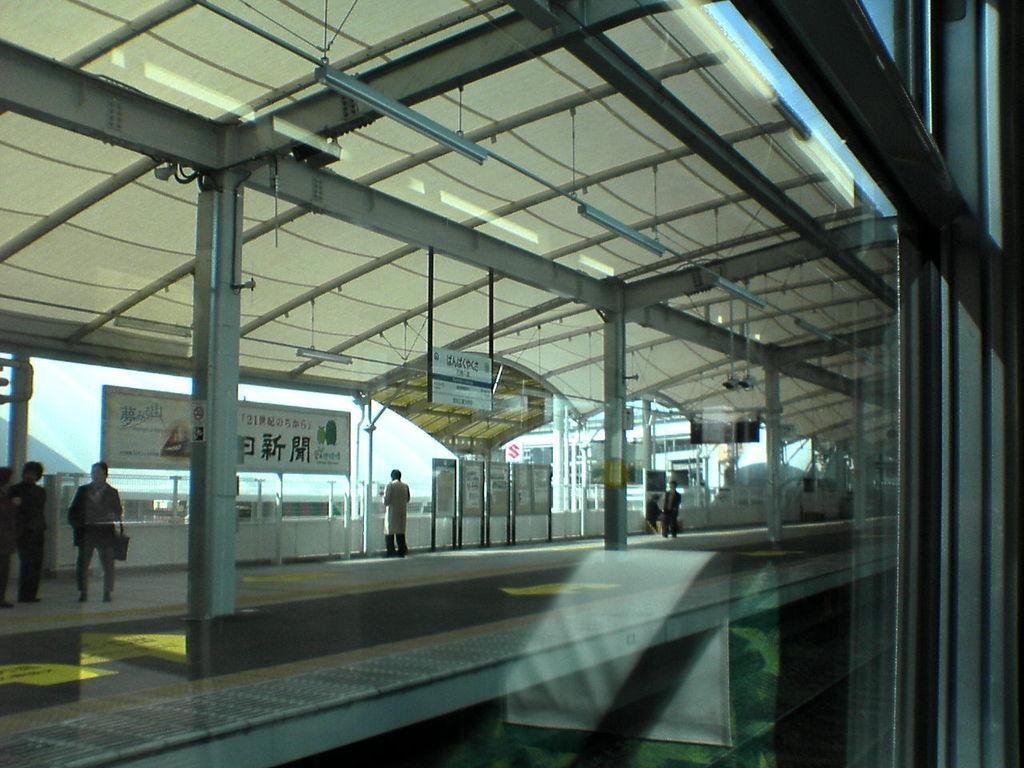Describe this image in one or two sentences. In the picture we can see a from the window glass, outside it, we can see a shed with a pillar and some people walking on the path and on the ceiling we can see some lights, boards. 